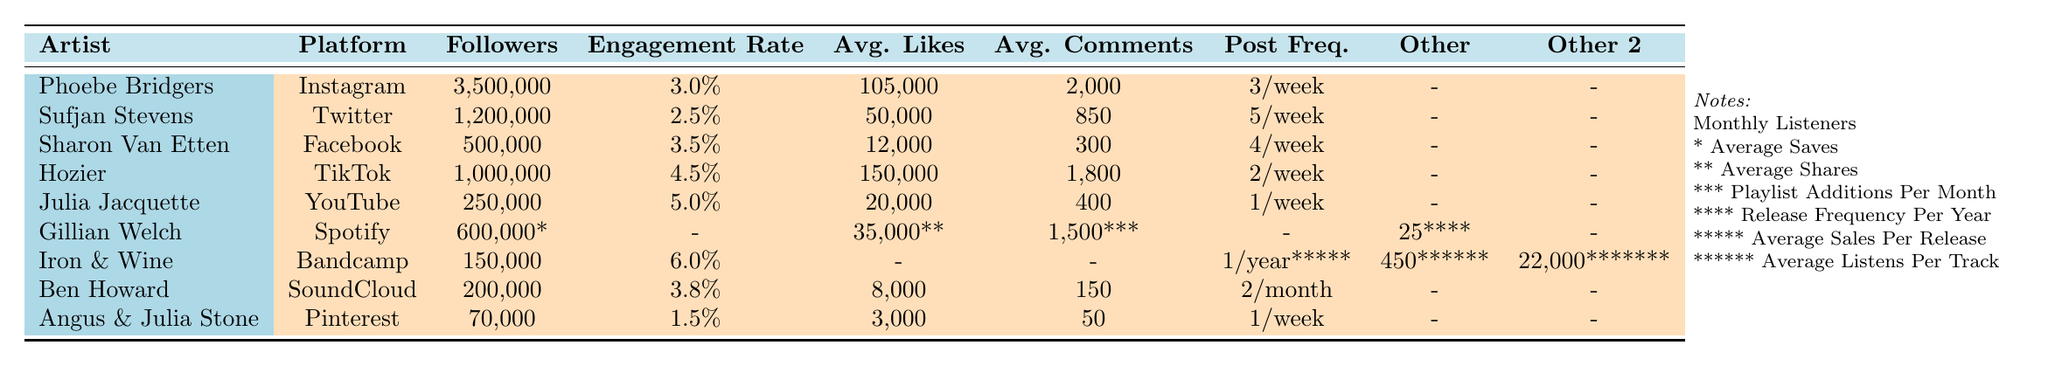What's the engagement rate of Phoebe Bridgers on Instagram? The table shows that Phoebe Bridgers has an engagement rate of 3.0% on Instagram.
Answer: 3.0% Which artist has the highest average likes per post on TikTok? Hozier has the highest average likes, which is 150,000 on TikTok.
Answer: Hozier What is the average number of followers for artists listed on Twitter? The table shows Sufjan Stevens has 1,200,000 followers on Twitter. So, the average for this specific artist is 1,200,000 as there is only one artist on this platform.
Answer: 1,200,000 Which platform has the highest engagement rate, and what is that rate? According to the table, Iron & Wine on Bandcamp has the highest engagement rate of 6.0%.
Answer: 6.0% How many total comments does Sharon Van Etten receive, on average, per week on Facebook? Sharon Van Etten's average comments are 300 per post, and she posts 4 times a week, so she receives 300 * 4 = 1,200 comments on average per week.
Answer: 1,200 Is the engagement rate for Angus & Julia Stone on Pinterest higher than 2%? The table shows that Angus & Julia Stone has an engagement rate of 1.5%, which is lower than 2%.
Answer: No Calculate the average engagement rate of the indie artists listed in the table. The engagement rates are 3.0%, 2.5%, 3.5%, 4.5%, 5.0%, 6.0%, 3.8%, and 1.5%. Summing these gives 30.8%, and dividing by the number of artists (8) gives an average engagement rate of 3.85%.
Answer: 3.85% Which artist has the lowest number of total followers, and what is that number? Looking at the table, Angus & Julia Stone has the lowest follower count with 70,000 on Pinterest.
Answer: 70,000 If Hozier increased his post frequency on TikTok to 3 per week, what would the new average likes be per post, assuming likes remain the same? Hozier currently has 150,000 likes for 2 posts per week, which equals an average of 75,000 likes per post. If the frequency increases to 3 posts, the likes per post remain the same because total likes are unchanged, thus remaining at 150,000 total likes divided by 3, which gives an average of 50,000 likes per post.
Answer: 50,000 How many more average comments does Phoebe Bridgers receive compared to the average comments of Ben Howard on SoundCloud? Phoebe Bridgers gets 2,000 average comments, while Ben Howard gets 150. The difference is 2,000 - 150 = 1,850 comments.
Answer: 1,850 